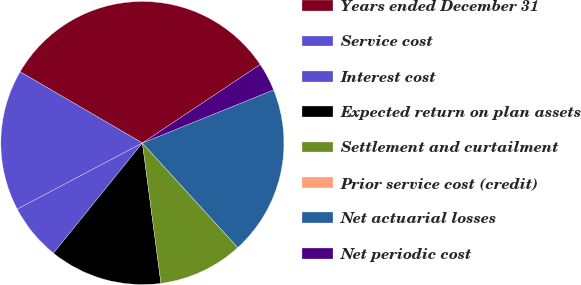Convert chart. <chart><loc_0><loc_0><loc_500><loc_500><pie_chart><fcel>Years ended December 31<fcel>Service cost<fcel>Interest cost<fcel>Expected return on plan assets<fcel>Settlement and curtailment<fcel>Prior service cost (credit)<fcel>Net actuarial losses<fcel>Net periodic cost<nl><fcel>32.25%<fcel>16.13%<fcel>6.45%<fcel>12.9%<fcel>9.68%<fcel>0.0%<fcel>19.35%<fcel>3.23%<nl></chart> 